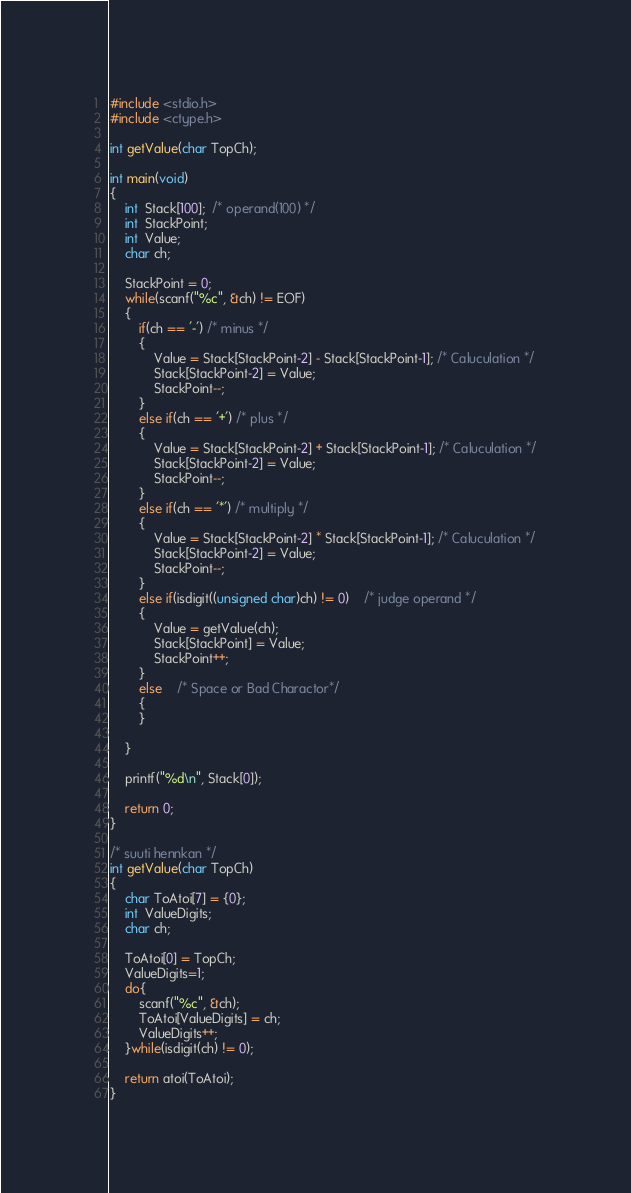Convert code to text. <code><loc_0><loc_0><loc_500><loc_500><_C_>#include <stdio.h>
#include <ctype.h>

int getValue(char TopCh);

int main(void)
{
	int  Stack[100];  /* operand(100) */
	int  StackPoint;
	int  Value;
	char ch;
	
	StackPoint = 0;
	while(scanf("%c", &ch) != EOF)
	{
		if(ch == '-') /* minus */
		{
			Value = Stack[StackPoint-2] - Stack[StackPoint-1]; /* Caluculation */
			Stack[StackPoint-2] = Value;
			StackPoint--;
		}
		else if(ch == '+') /* plus */
		{
			Value = Stack[StackPoint-2] + Stack[StackPoint-1]; /* Caluculation */
			Stack[StackPoint-2] = Value;
			StackPoint--;
		}
		else if(ch == '*') /* multiply */
		{
			Value = Stack[StackPoint-2] * Stack[StackPoint-1]; /* Caluculation */
			Stack[StackPoint-2] = Value;
			StackPoint--;
		}
		else if(isdigit((unsigned char)ch) != 0)	/* judge operand */
		{
			Value = getValue(ch);
			Stack[StackPoint] = Value;
			StackPoint++;
		}
		else	/* Space or Bad Charactor*/
		{
		}
		
	}
	
	printf("%d\n", Stack[0]);
	
	return 0;
}

/* suuti hennkan */
int getValue(char TopCh)
{
	char ToAtoi[7] = {0};
	int  ValueDigits;
	char ch;
	
	ToAtoi[0] = TopCh;
	ValueDigits=1;
	do{
		scanf("%c", &ch);
		ToAtoi[ValueDigits] = ch;
		ValueDigits++;
	}while(isdigit(ch) != 0);
	
	return atoi(ToAtoi);
}</code> 